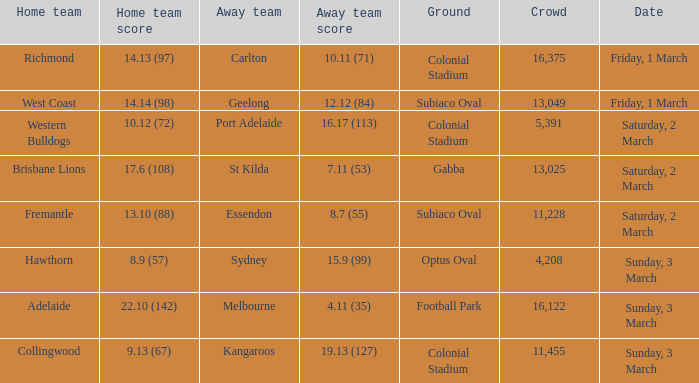What was the ground for away team sydney? Optus Oval. 